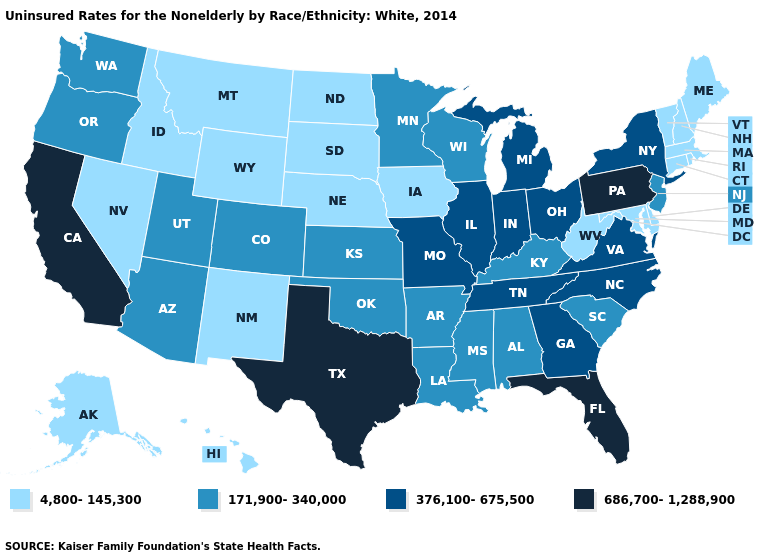Which states hav the highest value in the South?
Be succinct. Florida, Texas. Name the states that have a value in the range 171,900-340,000?
Concise answer only. Alabama, Arizona, Arkansas, Colorado, Kansas, Kentucky, Louisiana, Minnesota, Mississippi, New Jersey, Oklahoma, Oregon, South Carolina, Utah, Washington, Wisconsin. What is the value of Virginia?
Answer briefly. 376,100-675,500. Which states hav the highest value in the South?
Quick response, please. Florida, Texas. What is the value of Montana?
Short answer required. 4,800-145,300. What is the lowest value in states that border Utah?
Keep it brief. 4,800-145,300. Name the states that have a value in the range 4,800-145,300?
Be succinct. Alaska, Connecticut, Delaware, Hawaii, Idaho, Iowa, Maine, Maryland, Massachusetts, Montana, Nebraska, Nevada, New Hampshire, New Mexico, North Dakota, Rhode Island, South Dakota, Vermont, West Virginia, Wyoming. What is the value of Alaska?
Be succinct. 4,800-145,300. What is the lowest value in the USA?
Write a very short answer. 4,800-145,300. Name the states that have a value in the range 686,700-1,288,900?
Concise answer only. California, Florida, Pennsylvania, Texas. Name the states that have a value in the range 376,100-675,500?
Concise answer only. Georgia, Illinois, Indiana, Michigan, Missouri, New York, North Carolina, Ohio, Tennessee, Virginia. Does Kentucky have the same value as Oklahoma?
Give a very brief answer. Yes. What is the value of California?
Concise answer only. 686,700-1,288,900. What is the highest value in the Northeast ?
Write a very short answer. 686,700-1,288,900. What is the lowest value in states that border Maryland?
Keep it brief. 4,800-145,300. 